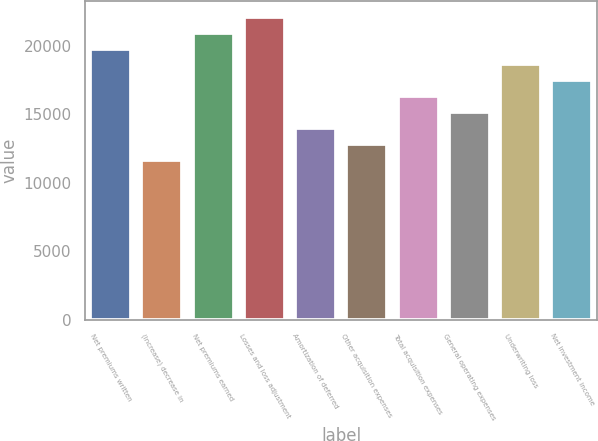Convert chart to OTSL. <chart><loc_0><loc_0><loc_500><loc_500><bar_chart><fcel>Net premiums written<fcel>(Increase) decrease in<fcel>Net premiums earned<fcel>Losses and loss adjustment<fcel>Amortization of deferred<fcel>Other acquisition expenses<fcel>Total acquisition expenses<fcel>General operating expenses<fcel>Underwriting loss<fcel>Net investment income<nl><fcel>19795.7<fcel>11646<fcel>20959.9<fcel>22124.2<fcel>13974.5<fcel>12810.2<fcel>16303<fcel>15138.7<fcel>18631.4<fcel>17467.2<nl></chart> 